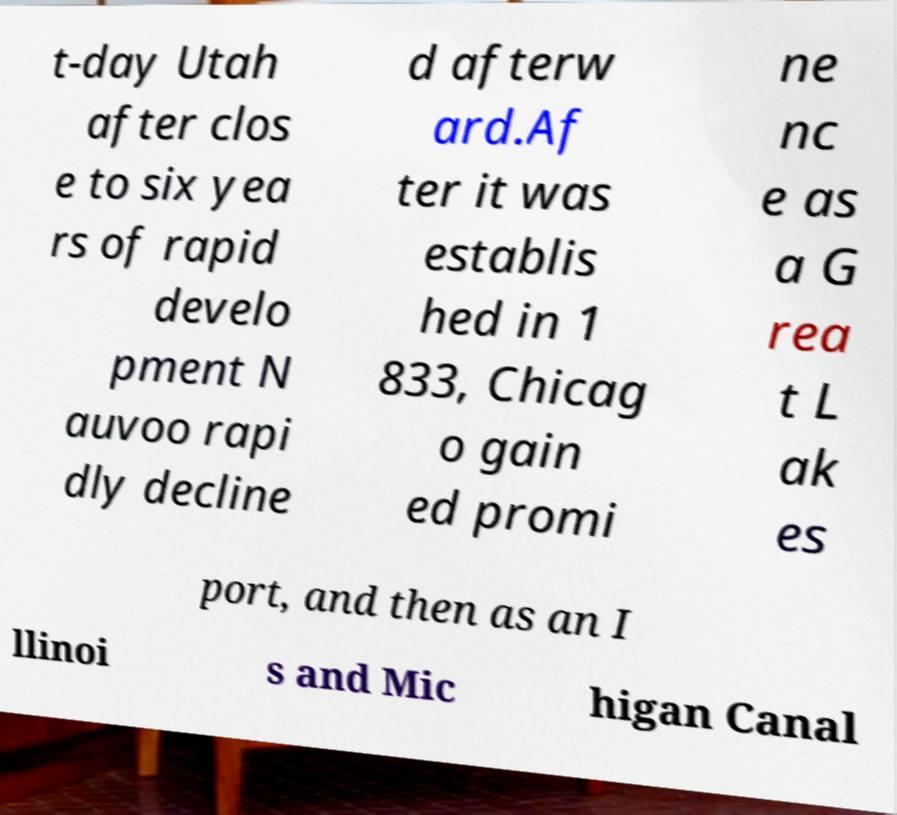Can you accurately transcribe the text from the provided image for me? t-day Utah after clos e to six yea rs of rapid develo pment N auvoo rapi dly decline d afterw ard.Af ter it was establis hed in 1 833, Chicag o gain ed promi ne nc e as a G rea t L ak es port, and then as an I llinoi s and Mic higan Canal 